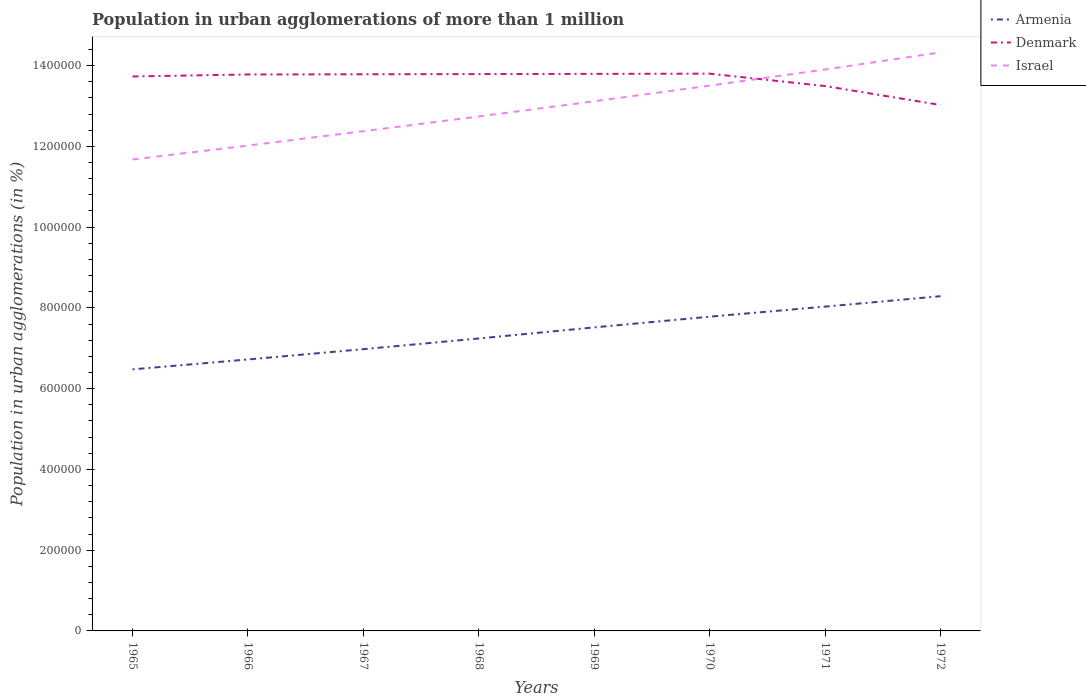Does the line corresponding to Armenia intersect with the line corresponding to Israel?
Your answer should be very brief. No. Across all years, what is the maximum population in urban agglomerations in Armenia?
Offer a very short reply. 6.48e+05. In which year was the population in urban agglomerations in Israel maximum?
Make the answer very short. 1965. What is the total population in urban agglomerations in Israel in the graph?
Offer a terse response. -2.65e+05. What is the difference between the highest and the second highest population in urban agglomerations in Armenia?
Your answer should be very brief. 1.81e+05. What is the difference between two consecutive major ticks on the Y-axis?
Your response must be concise. 2.00e+05. Does the graph contain any zero values?
Give a very brief answer. No. Does the graph contain grids?
Your answer should be compact. No. Where does the legend appear in the graph?
Give a very brief answer. Top right. How are the legend labels stacked?
Give a very brief answer. Vertical. What is the title of the graph?
Provide a short and direct response. Population in urban agglomerations of more than 1 million. What is the label or title of the X-axis?
Provide a succinct answer. Years. What is the label or title of the Y-axis?
Your answer should be very brief. Population in urban agglomerations (in %). What is the Population in urban agglomerations (in %) in Armenia in 1965?
Your answer should be compact. 6.48e+05. What is the Population in urban agglomerations (in %) in Denmark in 1965?
Provide a short and direct response. 1.37e+06. What is the Population in urban agglomerations (in %) of Israel in 1965?
Offer a very short reply. 1.17e+06. What is the Population in urban agglomerations (in %) of Armenia in 1966?
Your answer should be very brief. 6.72e+05. What is the Population in urban agglomerations (in %) of Denmark in 1966?
Make the answer very short. 1.38e+06. What is the Population in urban agglomerations (in %) in Israel in 1966?
Offer a terse response. 1.20e+06. What is the Population in urban agglomerations (in %) of Armenia in 1967?
Ensure brevity in your answer.  6.98e+05. What is the Population in urban agglomerations (in %) of Denmark in 1967?
Your answer should be very brief. 1.38e+06. What is the Population in urban agglomerations (in %) of Israel in 1967?
Provide a succinct answer. 1.24e+06. What is the Population in urban agglomerations (in %) of Armenia in 1968?
Keep it short and to the point. 7.24e+05. What is the Population in urban agglomerations (in %) in Denmark in 1968?
Offer a very short reply. 1.38e+06. What is the Population in urban agglomerations (in %) of Israel in 1968?
Your answer should be very brief. 1.27e+06. What is the Population in urban agglomerations (in %) of Armenia in 1969?
Give a very brief answer. 7.52e+05. What is the Population in urban agglomerations (in %) of Denmark in 1969?
Keep it short and to the point. 1.38e+06. What is the Population in urban agglomerations (in %) in Israel in 1969?
Offer a very short reply. 1.31e+06. What is the Population in urban agglomerations (in %) in Armenia in 1970?
Offer a very short reply. 7.78e+05. What is the Population in urban agglomerations (in %) in Denmark in 1970?
Ensure brevity in your answer.  1.38e+06. What is the Population in urban agglomerations (in %) in Israel in 1970?
Offer a terse response. 1.35e+06. What is the Population in urban agglomerations (in %) of Armenia in 1971?
Your answer should be very brief. 8.03e+05. What is the Population in urban agglomerations (in %) in Denmark in 1971?
Your answer should be compact. 1.35e+06. What is the Population in urban agglomerations (in %) of Israel in 1971?
Give a very brief answer. 1.39e+06. What is the Population in urban agglomerations (in %) of Armenia in 1972?
Your answer should be very brief. 8.29e+05. What is the Population in urban agglomerations (in %) in Denmark in 1972?
Offer a very short reply. 1.30e+06. What is the Population in urban agglomerations (in %) in Israel in 1972?
Give a very brief answer. 1.43e+06. Across all years, what is the maximum Population in urban agglomerations (in %) in Armenia?
Your answer should be very brief. 8.29e+05. Across all years, what is the maximum Population in urban agglomerations (in %) in Denmark?
Keep it short and to the point. 1.38e+06. Across all years, what is the maximum Population in urban agglomerations (in %) in Israel?
Ensure brevity in your answer.  1.43e+06. Across all years, what is the minimum Population in urban agglomerations (in %) in Armenia?
Ensure brevity in your answer.  6.48e+05. Across all years, what is the minimum Population in urban agglomerations (in %) in Denmark?
Offer a very short reply. 1.30e+06. Across all years, what is the minimum Population in urban agglomerations (in %) of Israel?
Ensure brevity in your answer.  1.17e+06. What is the total Population in urban agglomerations (in %) in Armenia in the graph?
Offer a terse response. 5.90e+06. What is the total Population in urban agglomerations (in %) in Denmark in the graph?
Your answer should be compact. 1.09e+07. What is the total Population in urban agglomerations (in %) in Israel in the graph?
Your answer should be very brief. 1.04e+07. What is the difference between the Population in urban agglomerations (in %) of Armenia in 1965 and that in 1966?
Make the answer very short. -2.46e+04. What is the difference between the Population in urban agglomerations (in %) in Denmark in 1965 and that in 1966?
Provide a short and direct response. -4922. What is the difference between the Population in urban agglomerations (in %) of Israel in 1965 and that in 1966?
Keep it short and to the point. -3.45e+04. What is the difference between the Population in urban agglomerations (in %) of Armenia in 1965 and that in 1967?
Ensure brevity in your answer.  -5.00e+04. What is the difference between the Population in urban agglomerations (in %) in Denmark in 1965 and that in 1967?
Make the answer very short. -5430. What is the difference between the Population in urban agglomerations (in %) of Israel in 1965 and that in 1967?
Your answer should be compact. -6.99e+04. What is the difference between the Population in urban agglomerations (in %) of Armenia in 1965 and that in 1968?
Provide a succinct answer. -7.65e+04. What is the difference between the Population in urban agglomerations (in %) of Denmark in 1965 and that in 1968?
Ensure brevity in your answer.  -5938. What is the difference between the Population in urban agglomerations (in %) in Israel in 1965 and that in 1968?
Give a very brief answer. -1.07e+05. What is the difference between the Population in urban agglomerations (in %) of Armenia in 1965 and that in 1969?
Your response must be concise. -1.04e+05. What is the difference between the Population in urban agglomerations (in %) in Denmark in 1965 and that in 1969?
Provide a succinct answer. -6445. What is the difference between the Population in urban agglomerations (in %) in Israel in 1965 and that in 1969?
Provide a succinct answer. -1.44e+05. What is the difference between the Population in urban agglomerations (in %) of Armenia in 1965 and that in 1970?
Your answer should be compact. -1.30e+05. What is the difference between the Population in urban agglomerations (in %) in Denmark in 1965 and that in 1970?
Your answer should be very brief. -6954. What is the difference between the Population in urban agglomerations (in %) in Israel in 1965 and that in 1970?
Give a very brief answer. -1.83e+05. What is the difference between the Population in urban agglomerations (in %) in Armenia in 1965 and that in 1971?
Provide a succinct answer. -1.55e+05. What is the difference between the Population in urban agglomerations (in %) of Denmark in 1965 and that in 1971?
Your answer should be compact. 2.37e+04. What is the difference between the Population in urban agglomerations (in %) of Israel in 1965 and that in 1971?
Ensure brevity in your answer.  -2.23e+05. What is the difference between the Population in urban agglomerations (in %) in Armenia in 1965 and that in 1972?
Your answer should be compact. -1.81e+05. What is the difference between the Population in urban agglomerations (in %) in Denmark in 1965 and that in 1972?
Give a very brief answer. 7.06e+04. What is the difference between the Population in urban agglomerations (in %) in Israel in 1965 and that in 1972?
Provide a succinct answer. -2.65e+05. What is the difference between the Population in urban agglomerations (in %) in Armenia in 1966 and that in 1967?
Offer a terse response. -2.55e+04. What is the difference between the Population in urban agglomerations (in %) in Denmark in 1966 and that in 1967?
Provide a succinct answer. -508. What is the difference between the Population in urban agglomerations (in %) of Israel in 1966 and that in 1967?
Make the answer very short. -3.55e+04. What is the difference between the Population in urban agglomerations (in %) of Armenia in 1966 and that in 1968?
Make the answer very short. -5.20e+04. What is the difference between the Population in urban agglomerations (in %) of Denmark in 1966 and that in 1968?
Ensure brevity in your answer.  -1016. What is the difference between the Population in urban agglomerations (in %) of Israel in 1966 and that in 1968?
Keep it short and to the point. -7.21e+04. What is the difference between the Population in urban agglomerations (in %) in Armenia in 1966 and that in 1969?
Offer a very short reply. -7.94e+04. What is the difference between the Population in urban agglomerations (in %) in Denmark in 1966 and that in 1969?
Your answer should be very brief. -1523. What is the difference between the Population in urban agglomerations (in %) in Israel in 1966 and that in 1969?
Your response must be concise. -1.10e+05. What is the difference between the Population in urban agglomerations (in %) of Armenia in 1966 and that in 1970?
Offer a terse response. -1.06e+05. What is the difference between the Population in urban agglomerations (in %) in Denmark in 1966 and that in 1970?
Make the answer very short. -2032. What is the difference between the Population in urban agglomerations (in %) of Israel in 1966 and that in 1970?
Give a very brief answer. -1.48e+05. What is the difference between the Population in urban agglomerations (in %) of Armenia in 1966 and that in 1971?
Your answer should be very brief. -1.31e+05. What is the difference between the Population in urban agglomerations (in %) of Denmark in 1966 and that in 1971?
Provide a succinct answer. 2.87e+04. What is the difference between the Population in urban agglomerations (in %) of Israel in 1966 and that in 1971?
Offer a terse response. -1.88e+05. What is the difference between the Population in urban agglomerations (in %) of Armenia in 1966 and that in 1972?
Offer a very short reply. -1.57e+05. What is the difference between the Population in urban agglomerations (in %) in Denmark in 1966 and that in 1972?
Keep it short and to the point. 7.55e+04. What is the difference between the Population in urban agglomerations (in %) in Israel in 1966 and that in 1972?
Provide a succinct answer. -2.31e+05. What is the difference between the Population in urban agglomerations (in %) of Armenia in 1967 and that in 1968?
Your answer should be compact. -2.65e+04. What is the difference between the Population in urban agglomerations (in %) of Denmark in 1967 and that in 1968?
Your response must be concise. -508. What is the difference between the Population in urban agglomerations (in %) of Israel in 1967 and that in 1968?
Make the answer very short. -3.66e+04. What is the difference between the Population in urban agglomerations (in %) in Armenia in 1967 and that in 1969?
Keep it short and to the point. -5.39e+04. What is the difference between the Population in urban agglomerations (in %) in Denmark in 1967 and that in 1969?
Your response must be concise. -1015. What is the difference between the Population in urban agglomerations (in %) of Israel in 1967 and that in 1969?
Make the answer very short. -7.42e+04. What is the difference between the Population in urban agglomerations (in %) of Armenia in 1967 and that in 1970?
Your answer should be compact. -8.04e+04. What is the difference between the Population in urban agglomerations (in %) of Denmark in 1967 and that in 1970?
Your response must be concise. -1524. What is the difference between the Population in urban agglomerations (in %) of Israel in 1967 and that in 1970?
Provide a succinct answer. -1.13e+05. What is the difference between the Population in urban agglomerations (in %) in Armenia in 1967 and that in 1971?
Provide a short and direct response. -1.05e+05. What is the difference between the Population in urban agglomerations (in %) in Denmark in 1967 and that in 1971?
Your answer should be very brief. 2.92e+04. What is the difference between the Population in urban agglomerations (in %) of Israel in 1967 and that in 1971?
Make the answer very short. -1.53e+05. What is the difference between the Population in urban agglomerations (in %) of Armenia in 1967 and that in 1972?
Your response must be concise. -1.31e+05. What is the difference between the Population in urban agglomerations (in %) of Denmark in 1967 and that in 1972?
Give a very brief answer. 7.60e+04. What is the difference between the Population in urban agglomerations (in %) in Israel in 1967 and that in 1972?
Keep it short and to the point. -1.95e+05. What is the difference between the Population in urban agglomerations (in %) in Armenia in 1968 and that in 1969?
Provide a short and direct response. -2.74e+04. What is the difference between the Population in urban agglomerations (in %) of Denmark in 1968 and that in 1969?
Give a very brief answer. -507. What is the difference between the Population in urban agglomerations (in %) in Israel in 1968 and that in 1969?
Provide a short and direct response. -3.76e+04. What is the difference between the Population in urban agglomerations (in %) of Armenia in 1968 and that in 1970?
Your answer should be compact. -5.39e+04. What is the difference between the Population in urban agglomerations (in %) in Denmark in 1968 and that in 1970?
Your answer should be very brief. -1016. What is the difference between the Population in urban agglomerations (in %) in Israel in 1968 and that in 1970?
Provide a succinct answer. -7.64e+04. What is the difference between the Population in urban agglomerations (in %) of Armenia in 1968 and that in 1971?
Make the answer very short. -7.89e+04. What is the difference between the Population in urban agglomerations (in %) in Denmark in 1968 and that in 1971?
Your response must be concise. 2.97e+04. What is the difference between the Population in urban agglomerations (in %) in Israel in 1968 and that in 1971?
Offer a very short reply. -1.16e+05. What is the difference between the Population in urban agglomerations (in %) in Armenia in 1968 and that in 1972?
Ensure brevity in your answer.  -1.05e+05. What is the difference between the Population in urban agglomerations (in %) of Denmark in 1968 and that in 1972?
Provide a succinct answer. 7.65e+04. What is the difference between the Population in urban agglomerations (in %) of Israel in 1968 and that in 1972?
Make the answer very short. -1.59e+05. What is the difference between the Population in urban agglomerations (in %) of Armenia in 1969 and that in 1970?
Offer a very short reply. -2.65e+04. What is the difference between the Population in urban agglomerations (in %) in Denmark in 1969 and that in 1970?
Ensure brevity in your answer.  -509. What is the difference between the Population in urban agglomerations (in %) of Israel in 1969 and that in 1970?
Provide a succinct answer. -3.88e+04. What is the difference between the Population in urban agglomerations (in %) in Armenia in 1969 and that in 1971?
Offer a terse response. -5.14e+04. What is the difference between the Population in urban agglomerations (in %) of Denmark in 1969 and that in 1971?
Make the answer very short. 3.02e+04. What is the difference between the Population in urban agglomerations (in %) of Israel in 1969 and that in 1971?
Provide a short and direct response. -7.87e+04. What is the difference between the Population in urban agglomerations (in %) in Armenia in 1969 and that in 1972?
Offer a terse response. -7.72e+04. What is the difference between the Population in urban agglomerations (in %) in Denmark in 1969 and that in 1972?
Your answer should be compact. 7.70e+04. What is the difference between the Population in urban agglomerations (in %) in Israel in 1969 and that in 1972?
Your response must be concise. -1.21e+05. What is the difference between the Population in urban agglomerations (in %) in Armenia in 1970 and that in 1971?
Give a very brief answer. -2.50e+04. What is the difference between the Population in urban agglomerations (in %) in Denmark in 1970 and that in 1971?
Offer a terse response. 3.07e+04. What is the difference between the Population in urban agglomerations (in %) in Israel in 1970 and that in 1971?
Your answer should be compact. -3.99e+04. What is the difference between the Population in urban agglomerations (in %) of Armenia in 1970 and that in 1972?
Offer a terse response. -5.07e+04. What is the difference between the Population in urban agglomerations (in %) of Denmark in 1970 and that in 1972?
Provide a short and direct response. 7.76e+04. What is the difference between the Population in urban agglomerations (in %) in Israel in 1970 and that in 1972?
Give a very brief answer. -8.22e+04. What is the difference between the Population in urban agglomerations (in %) in Armenia in 1971 and that in 1972?
Provide a short and direct response. -2.58e+04. What is the difference between the Population in urban agglomerations (in %) of Denmark in 1971 and that in 1972?
Your answer should be compact. 4.69e+04. What is the difference between the Population in urban agglomerations (in %) of Israel in 1971 and that in 1972?
Your answer should be very brief. -4.23e+04. What is the difference between the Population in urban agglomerations (in %) in Armenia in 1965 and the Population in urban agglomerations (in %) in Denmark in 1966?
Give a very brief answer. -7.30e+05. What is the difference between the Population in urban agglomerations (in %) of Armenia in 1965 and the Population in urban agglomerations (in %) of Israel in 1966?
Provide a short and direct response. -5.54e+05. What is the difference between the Population in urban agglomerations (in %) of Denmark in 1965 and the Population in urban agglomerations (in %) of Israel in 1966?
Offer a terse response. 1.71e+05. What is the difference between the Population in urban agglomerations (in %) in Armenia in 1965 and the Population in urban agglomerations (in %) in Denmark in 1967?
Keep it short and to the point. -7.31e+05. What is the difference between the Population in urban agglomerations (in %) of Armenia in 1965 and the Population in urban agglomerations (in %) of Israel in 1967?
Provide a short and direct response. -5.90e+05. What is the difference between the Population in urban agglomerations (in %) of Denmark in 1965 and the Population in urban agglomerations (in %) of Israel in 1967?
Your response must be concise. 1.36e+05. What is the difference between the Population in urban agglomerations (in %) in Armenia in 1965 and the Population in urban agglomerations (in %) in Denmark in 1968?
Your response must be concise. -7.31e+05. What is the difference between the Population in urban agglomerations (in %) in Armenia in 1965 and the Population in urban agglomerations (in %) in Israel in 1968?
Provide a short and direct response. -6.26e+05. What is the difference between the Population in urban agglomerations (in %) in Denmark in 1965 and the Population in urban agglomerations (in %) in Israel in 1968?
Provide a short and direct response. 9.90e+04. What is the difference between the Population in urban agglomerations (in %) in Armenia in 1965 and the Population in urban agglomerations (in %) in Denmark in 1969?
Your answer should be very brief. -7.32e+05. What is the difference between the Population in urban agglomerations (in %) in Armenia in 1965 and the Population in urban agglomerations (in %) in Israel in 1969?
Make the answer very short. -6.64e+05. What is the difference between the Population in urban agglomerations (in %) in Denmark in 1965 and the Population in urban agglomerations (in %) in Israel in 1969?
Your answer should be compact. 6.14e+04. What is the difference between the Population in urban agglomerations (in %) of Armenia in 1965 and the Population in urban agglomerations (in %) of Denmark in 1970?
Provide a short and direct response. -7.32e+05. What is the difference between the Population in urban agglomerations (in %) of Armenia in 1965 and the Population in urban agglomerations (in %) of Israel in 1970?
Offer a very short reply. -7.03e+05. What is the difference between the Population in urban agglomerations (in %) in Denmark in 1965 and the Population in urban agglomerations (in %) in Israel in 1970?
Offer a very short reply. 2.27e+04. What is the difference between the Population in urban agglomerations (in %) in Armenia in 1965 and the Population in urban agglomerations (in %) in Denmark in 1971?
Provide a short and direct response. -7.02e+05. What is the difference between the Population in urban agglomerations (in %) in Armenia in 1965 and the Population in urban agglomerations (in %) in Israel in 1971?
Offer a terse response. -7.43e+05. What is the difference between the Population in urban agglomerations (in %) of Denmark in 1965 and the Population in urban agglomerations (in %) of Israel in 1971?
Provide a succinct answer. -1.73e+04. What is the difference between the Population in urban agglomerations (in %) of Armenia in 1965 and the Population in urban agglomerations (in %) of Denmark in 1972?
Offer a very short reply. -6.55e+05. What is the difference between the Population in urban agglomerations (in %) of Armenia in 1965 and the Population in urban agglomerations (in %) of Israel in 1972?
Provide a succinct answer. -7.85e+05. What is the difference between the Population in urban agglomerations (in %) of Denmark in 1965 and the Population in urban agglomerations (in %) of Israel in 1972?
Offer a very short reply. -5.95e+04. What is the difference between the Population in urban agglomerations (in %) of Armenia in 1966 and the Population in urban agglomerations (in %) of Denmark in 1967?
Your answer should be very brief. -7.06e+05. What is the difference between the Population in urban agglomerations (in %) in Armenia in 1966 and the Population in urban agglomerations (in %) in Israel in 1967?
Give a very brief answer. -5.65e+05. What is the difference between the Population in urban agglomerations (in %) in Denmark in 1966 and the Population in urban agglomerations (in %) in Israel in 1967?
Your answer should be compact. 1.41e+05. What is the difference between the Population in urban agglomerations (in %) of Armenia in 1966 and the Population in urban agglomerations (in %) of Denmark in 1968?
Offer a terse response. -7.07e+05. What is the difference between the Population in urban agglomerations (in %) of Armenia in 1966 and the Population in urban agglomerations (in %) of Israel in 1968?
Provide a succinct answer. -6.02e+05. What is the difference between the Population in urban agglomerations (in %) in Denmark in 1966 and the Population in urban agglomerations (in %) in Israel in 1968?
Make the answer very short. 1.04e+05. What is the difference between the Population in urban agglomerations (in %) in Armenia in 1966 and the Population in urban agglomerations (in %) in Denmark in 1969?
Provide a succinct answer. -7.07e+05. What is the difference between the Population in urban agglomerations (in %) of Armenia in 1966 and the Population in urban agglomerations (in %) of Israel in 1969?
Provide a short and direct response. -6.39e+05. What is the difference between the Population in urban agglomerations (in %) in Denmark in 1966 and the Population in urban agglomerations (in %) in Israel in 1969?
Keep it short and to the point. 6.64e+04. What is the difference between the Population in urban agglomerations (in %) in Armenia in 1966 and the Population in urban agglomerations (in %) in Denmark in 1970?
Offer a very short reply. -7.08e+05. What is the difference between the Population in urban agglomerations (in %) in Armenia in 1966 and the Population in urban agglomerations (in %) in Israel in 1970?
Offer a terse response. -6.78e+05. What is the difference between the Population in urban agglomerations (in %) in Denmark in 1966 and the Population in urban agglomerations (in %) in Israel in 1970?
Your response must be concise. 2.76e+04. What is the difference between the Population in urban agglomerations (in %) in Armenia in 1966 and the Population in urban agglomerations (in %) in Denmark in 1971?
Keep it short and to the point. -6.77e+05. What is the difference between the Population in urban agglomerations (in %) in Armenia in 1966 and the Population in urban agglomerations (in %) in Israel in 1971?
Your answer should be compact. -7.18e+05. What is the difference between the Population in urban agglomerations (in %) of Denmark in 1966 and the Population in urban agglomerations (in %) of Israel in 1971?
Provide a short and direct response. -1.23e+04. What is the difference between the Population in urban agglomerations (in %) of Armenia in 1966 and the Population in urban agglomerations (in %) of Denmark in 1972?
Your answer should be very brief. -6.30e+05. What is the difference between the Population in urban agglomerations (in %) in Armenia in 1966 and the Population in urban agglomerations (in %) in Israel in 1972?
Keep it short and to the point. -7.60e+05. What is the difference between the Population in urban agglomerations (in %) in Denmark in 1966 and the Population in urban agglomerations (in %) in Israel in 1972?
Provide a short and direct response. -5.46e+04. What is the difference between the Population in urban agglomerations (in %) of Armenia in 1967 and the Population in urban agglomerations (in %) of Denmark in 1968?
Your response must be concise. -6.81e+05. What is the difference between the Population in urban agglomerations (in %) in Armenia in 1967 and the Population in urban agglomerations (in %) in Israel in 1968?
Ensure brevity in your answer.  -5.76e+05. What is the difference between the Population in urban agglomerations (in %) of Denmark in 1967 and the Population in urban agglomerations (in %) of Israel in 1968?
Your answer should be compact. 1.04e+05. What is the difference between the Population in urban agglomerations (in %) of Armenia in 1967 and the Population in urban agglomerations (in %) of Denmark in 1969?
Ensure brevity in your answer.  -6.82e+05. What is the difference between the Population in urban agglomerations (in %) in Armenia in 1967 and the Population in urban agglomerations (in %) in Israel in 1969?
Your answer should be compact. -6.14e+05. What is the difference between the Population in urban agglomerations (in %) of Denmark in 1967 and the Population in urban agglomerations (in %) of Israel in 1969?
Provide a short and direct response. 6.69e+04. What is the difference between the Population in urban agglomerations (in %) in Armenia in 1967 and the Population in urban agglomerations (in %) in Denmark in 1970?
Your answer should be very brief. -6.82e+05. What is the difference between the Population in urban agglomerations (in %) in Armenia in 1967 and the Population in urban agglomerations (in %) in Israel in 1970?
Give a very brief answer. -6.53e+05. What is the difference between the Population in urban agglomerations (in %) in Denmark in 1967 and the Population in urban agglomerations (in %) in Israel in 1970?
Keep it short and to the point. 2.81e+04. What is the difference between the Population in urban agglomerations (in %) in Armenia in 1967 and the Population in urban agglomerations (in %) in Denmark in 1971?
Your response must be concise. -6.52e+05. What is the difference between the Population in urban agglomerations (in %) of Armenia in 1967 and the Population in urban agglomerations (in %) of Israel in 1971?
Keep it short and to the point. -6.93e+05. What is the difference between the Population in urban agglomerations (in %) in Denmark in 1967 and the Population in urban agglomerations (in %) in Israel in 1971?
Provide a succinct answer. -1.18e+04. What is the difference between the Population in urban agglomerations (in %) of Armenia in 1967 and the Population in urban agglomerations (in %) of Denmark in 1972?
Your answer should be very brief. -6.05e+05. What is the difference between the Population in urban agglomerations (in %) in Armenia in 1967 and the Population in urban agglomerations (in %) in Israel in 1972?
Offer a terse response. -7.35e+05. What is the difference between the Population in urban agglomerations (in %) of Denmark in 1967 and the Population in urban agglomerations (in %) of Israel in 1972?
Give a very brief answer. -5.41e+04. What is the difference between the Population in urban agglomerations (in %) of Armenia in 1968 and the Population in urban agglomerations (in %) of Denmark in 1969?
Keep it short and to the point. -6.55e+05. What is the difference between the Population in urban agglomerations (in %) in Armenia in 1968 and the Population in urban agglomerations (in %) in Israel in 1969?
Your response must be concise. -5.87e+05. What is the difference between the Population in urban agglomerations (in %) in Denmark in 1968 and the Population in urban agglomerations (in %) in Israel in 1969?
Provide a succinct answer. 6.74e+04. What is the difference between the Population in urban agglomerations (in %) of Armenia in 1968 and the Population in urban agglomerations (in %) of Denmark in 1970?
Give a very brief answer. -6.56e+05. What is the difference between the Population in urban agglomerations (in %) in Armenia in 1968 and the Population in urban agglomerations (in %) in Israel in 1970?
Keep it short and to the point. -6.26e+05. What is the difference between the Population in urban agglomerations (in %) in Denmark in 1968 and the Population in urban agglomerations (in %) in Israel in 1970?
Offer a very short reply. 2.86e+04. What is the difference between the Population in urban agglomerations (in %) in Armenia in 1968 and the Population in urban agglomerations (in %) in Denmark in 1971?
Ensure brevity in your answer.  -6.25e+05. What is the difference between the Population in urban agglomerations (in %) of Armenia in 1968 and the Population in urban agglomerations (in %) of Israel in 1971?
Give a very brief answer. -6.66e+05. What is the difference between the Population in urban agglomerations (in %) of Denmark in 1968 and the Population in urban agglomerations (in %) of Israel in 1971?
Your response must be concise. -1.13e+04. What is the difference between the Population in urban agglomerations (in %) of Armenia in 1968 and the Population in urban agglomerations (in %) of Denmark in 1972?
Provide a short and direct response. -5.78e+05. What is the difference between the Population in urban agglomerations (in %) of Armenia in 1968 and the Population in urban agglomerations (in %) of Israel in 1972?
Provide a succinct answer. -7.08e+05. What is the difference between the Population in urban agglomerations (in %) in Denmark in 1968 and the Population in urban agglomerations (in %) in Israel in 1972?
Your response must be concise. -5.36e+04. What is the difference between the Population in urban agglomerations (in %) in Armenia in 1969 and the Population in urban agglomerations (in %) in Denmark in 1970?
Offer a terse response. -6.28e+05. What is the difference between the Population in urban agglomerations (in %) in Armenia in 1969 and the Population in urban agglomerations (in %) in Israel in 1970?
Keep it short and to the point. -5.99e+05. What is the difference between the Population in urban agglomerations (in %) of Denmark in 1969 and the Population in urban agglomerations (in %) of Israel in 1970?
Offer a terse response. 2.91e+04. What is the difference between the Population in urban agglomerations (in %) of Armenia in 1969 and the Population in urban agglomerations (in %) of Denmark in 1971?
Your answer should be very brief. -5.98e+05. What is the difference between the Population in urban agglomerations (in %) of Armenia in 1969 and the Population in urban agglomerations (in %) of Israel in 1971?
Your answer should be very brief. -6.39e+05. What is the difference between the Population in urban agglomerations (in %) in Denmark in 1969 and the Population in urban agglomerations (in %) in Israel in 1971?
Make the answer very short. -1.08e+04. What is the difference between the Population in urban agglomerations (in %) in Armenia in 1969 and the Population in urban agglomerations (in %) in Denmark in 1972?
Your response must be concise. -5.51e+05. What is the difference between the Population in urban agglomerations (in %) in Armenia in 1969 and the Population in urban agglomerations (in %) in Israel in 1972?
Offer a terse response. -6.81e+05. What is the difference between the Population in urban agglomerations (in %) in Denmark in 1969 and the Population in urban agglomerations (in %) in Israel in 1972?
Your answer should be compact. -5.31e+04. What is the difference between the Population in urban agglomerations (in %) in Armenia in 1970 and the Population in urban agglomerations (in %) in Denmark in 1971?
Provide a succinct answer. -5.71e+05. What is the difference between the Population in urban agglomerations (in %) of Armenia in 1970 and the Population in urban agglomerations (in %) of Israel in 1971?
Your response must be concise. -6.12e+05. What is the difference between the Population in urban agglomerations (in %) of Denmark in 1970 and the Population in urban agglomerations (in %) of Israel in 1971?
Provide a succinct answer. -1.03e+04. What is the difference between the Population in urban agglomerations (in %) in Armenia in 1970 and the Population in urban agglomerations (in %) in Denmark in 1972?
Your answer should be very brief. -5.24e+05. What is the difference between the Population in urban agglomerations (in %) of Armenia in 1970 and the Population in urban agglomerations (in %) of Israel in 1972?
Keep it short and to the point. -6.54e+05. What is the difference between the Population in urban agglomerations (in %) of Denmark in 1970 and the Population in urban agglomerations (in %) of Israel in 1972?
Your answer should be very brief. -5.26e+04. What is the difference between the Population in urban agglomerations (in %) of Armenia in 1971 and the Population in urban agglomerations (in %) of Denmark in 1972?
Give a very brief answer. -4.99e+05. What is the difference between the Population in urban agglomerations (in %) in Armenia in 1971 and the Population in urban agglomerations (in %) in Israel in 1972?
Your response must be concise. -6.29e+05. What is the difference between the Population in urban agglomerations (in %) in Denmark in 1971 and the Population in urban agglomerations (in %) in Israel in 1972?
Offer a terse response. -8.33e+04. What is the average Population in urban agglomerations (in %) of Armenia per year?
Your response must be concise. 7.38e+05. What is the average Population in urban agglomerations (in %) in Denmark per year?
Make the answer very short. 1.36e+06. What is the average Population in urban agglomerations (in %) of Israel per year?
Make the answer very short. 1.30e+06. In the year 1965, what is the difference between the Population in urban agglomerations (in %) of Armenia and Population in urban agglomerations (in %) of Denmark?
Offer a terse response. -7.25e+05. In the year 1965, what is the difference between the Population in urban agglomerations (in %) of Armenia and Population in urban agglomerations (in %) of Israel?
Your answer should be very brief. -5.20e+05. In the year 1965, what is the difference between the Population in urban agglomerations (in %) in Denmark and Population in urban agglomerations (in %) in Israel?
Offer a terse response. 2.06e+05. In the year 1966, what is the difference between the Population in urban agglomerations (in %) of Armenia and Population in urban agglomerations (in %) of Denmark?
Make the answer very short. -7.06e+05. In the year 1966, what is the difference between the Population in urban agglomerations (in %) in Armenia and Population in urban agglomerations (in %) in Israel?
Offer a very short reply. -5.30e+05. In the year 1966, what is the difference between the Population in urban agglomerations (in %) in Denmark and Population in urban agglomerations (in %) in Israel?
Provide a short and direct response. 1.76e+05. In the year 1967, what is the difference between the Population in urban agglomerations (in %) of Armenia and Population in urban agglomerations (in %) of Denmark?
Give a very brief answer. -6.81e+05. In the year 1967, what is the difference between the Population in urban agglomerations (in %) of Armenia and Population in urban agglomerations (in %) of Israel?
Keep it short and to the point. -5.40e+05. In the year 1967, what is the difference between the Population in urban agglomerations (in %) in Denmark and Population in urban agglomerations (in %) in Israel?
Offer a very short reply. 1.41e+05. In the year 1968, what is the difference between the Population in urban agglomerations (in %) of Armenia and Population in urban agglomerations (in %) of Denmark?
Provide a succinct answer. -6.55e+05. In the year 1968, what is the difference between the Population in urban agglomerations (in %) in Armenia and Population in urban agglomerations (in %) in Israel?
Offer a terse response. -5.50e+05. In the year 1968, what is the difference between the Population in urban agglomerations (in %) in Denmark and Population in urban agglomerations (in %) in Israel?
Provide a short and direct response. 1.05e+05. In the year 1969, what is the difference between the Population in urban agglomerations (in %) in Armenia and Population in urban agglomerations (in %) in Denmark?
Your answer should be compact. -6.28e+05. In the year 1969, what is the difference between the Population in urban agglomerations (in %) in Armenia and Population in urban agglomerations (in %) in Israel?
Keep it short and to the point. -5.60e+05. In the year 1969, what is the difference between the Population in urban agglomerations (in %) in Denmark and Population in urban agglomerations (in %) in Israel?
Your answer should be compact. 6.79e+04. In the year 1970, what is the difference between the Population in urban agglomerations (in %) in Armenia and Population in urban agglomerations (in %) in Denmark?
Offer a very short reply. -6.02e+05. In the year 1970, what is the difference between the Population in urban agglomerations (in %) in Armenia and Population in urban agglomerations (in %) in Israel?
Provide a succinct answer. -5.72e+05. In the year 1970, what is the difference between the Population in urban agglomerations (in %) of Denmark and Population in urban agglomerations (in %) of Israel?
Provide a succinct answer. 2.96e+04. In the year 1971, what is the difference between the Population in urban agglomerations (in %) in Armenia and Population in urban agglomerations (in %) in Denmark?
Offer a very short reply. -5.46e+05. In the year 1971, what is the difference between the Population in urban agglomerations (in %) in Armenia and Population in urban agglomerations (in %) in Israel?
Offer a very short reply. -5.87e+05. In the year 1971, what is the difference between the Population in urban agglomerations (in %) in Denmark and Population in urban agglomerations (in %) in Israel?
Your answer should be compact. -4.10e+04. In the year 1972, what is the difference between the Population in urban agglomerations (in %) in Armenia and Population in urban agglomerations (in %) in Denmark?
Offer a very short reply. -4.74e+05. In the year 1972, what is the difference between the Population in urban agglomerations (in %) of Armenia and Population in urban agglomerations (in %) of Israel?
Your answer should be compact. -6.04e+05. In the year 1972, what is the difference between the Population in urban agglomerations (in %) of Denmark and Population in urban agglomerations (in %) of Israel?
Give a very brief answer. -1.30e+05. What is the ratio of the Population in urban agglomerations (in %) in Armenia in 1965 to that in 1966?
Your answer should be very brief. 0.96. What is the ratio of the Population in urban agglomerations (in %) of Denmark in 1965 to that in 1966?
Provide a short and direct response. 1. What is the ratio of the Population in urban agglomerations (in %) of Israel in 1965 to that in 1966?
Provide a short and direct response. 0.97. What is the ratio of the Population in urban agglomerations (in %) in Armenia in 1965 to that in 1967?
Offer a very short reply. 0.93. What is the ratio of the Population in urban agglomerations (in %) of Denmark in 1965 to that in 1967?
Provide a succinct answer. 1. What is the ratio of the Population in urban agglomerations (in %) in Israel in 1965 to that in 1967?
Offer a terse response. 0.94. What is the ratio of the Population in urban agglomerations (in %) of Armenia in 1965 to that in 1968?
Your response must be concise. 0.89. What is the ratio of the Population in urban agglomerations (in %) in Denmark in 1965 to that in 1968?
Offer a terse response. 1. What is the ratio of the Population in urban agglomerations (in %) of Israel in 1965 to that in 1968?
Make the answer very short. 0.92. What is the ratio of the Population in urban agglomerations (in %) in Armenia in 1965 to that in 1969?
Provide a short and direct response. 0.86. What is the ratio of the Population in urban agglomerations (in %) of Israel in 1965 to that in 1969?
Provide a succinct answer. 0.89. What is the ratio of the Population in urban agglomerations (in %) in Armenia in 1965 to that in 1970?
Give a very brief answer. 0.83. What is the ratio of the Population in urban agglomerations (in %) of Denmark in 1965 to that in 1970?
Provide a short and direct response. 0.99. What is the ratio of the Population in urban agglomerations (in %) of Israel in 1965 to that in 1970?
Offer a terse response. 0.86. What is the ratio of the Population in urban agglomerations (in %) of Armenia in 1965 to that in 1971?
Make the answer very short. 0.81. What is the ratio of the Population in urban agglomerations (in %) of Denmark in 1965 to that in 1971?
Provide a short and direct response. 1.02. What is the ratio of the Population in urban agglomerations (in %) in Israel in 1965 to that in 1971?
Give a very brief answer. 0.84. What is the ratio of the Population in urban agglomerations (in %) of Armenia in 1965 to that in 1972?
Your answer should be very brief. 0.78. What is the ratio of the Population in urban agglomerations (in %) of Denmark in 1965 to that in 1972?
Offer a terse response. 1.05. What is the ratio of the Population in urban agglomerations (in %) in Israel in 1965 to that in 1972?
Your answer should be very brief. 0.81. What is the ratio of the Population in urban agglomerations (in %) in Armenia in 1966 to that in 1967?
Your answer should be compact. 0.96. What is the ratio of the Population in urban agglomerations (in %) in Israel in 1966 to that in 1967?
Give a very brief answer. 0.97. What is the ratio of the Population in urban agglomerations (in %) in Armenia in 1966 to that in 1968?
Give a very brief answer. 0.93. What is the ratio of the Population in urban agglomerations (in %) of Israel in 1966 to that in 1968?
Ensure brevity in your answer.  0.94. What is the ratio of the Population in urban agglomerations (in %) of Armenia in 1966 to that in 1969?
Your answer should be compact. 0.89. What is the ratio of the Population in urban agglomerations (in %) in Israel in 1966 to that in 1969?
Ensure brevity in your answer.  0.92. What is the ratio of the Population in urban agglomerations (in %) in Armenia in 1966 to that in 1970?
Keep it short and to the point. 0.86. What is the ratio of the Population in urban agglomerations (in %) in Denmark in 1966 to that in 1970?
Keep it short and to the point. 1. What is the ratio of the Population in urban agglomerations (in %) in Israel in 1966 to that in 1970?
Give a very brief answer. 0.89. What is the ratio of the Population in urban agglomerations (in %) in Armenia in 1966 to that in 1971?
Provide a succinct answer. 0.84. What is the ratio of the Population in urban agglomerations (in %) in Denmark in 1966 to that in 1971?
Offer a very short reply. 1.02. What is the ratio of the Population in urban agglomerations (in %) in Israel in 1966 to that in 1971?
Keep it short and to the point. 0.86. What is the ratio of the Population in urban agglomerations (in %) in Armenia in 1966 to that in 1972?
Make the answer very short. 0.81. What is the ratio of the Population in urban agglomerations (in %) in Denmark in 1966 to that in 1972?
Keep it short and to the point. 1.06. What is the ratio of the Population in urban agglomerations (in %) in Israel in 1966 to that in 1972?
Keep it short and to the point. 0.84. What is the ratio of the Population in urban agglomerations (in %) in Armenia in 1967 to that in 1968?
Give a very brief answer. 0.96. What is the ratio of the Population in urban agglomerations (in %) of Israel in 1967 to that in 1968?
Offer a very short reply. 0.97. What is the ratio of the Population in urban agglomerations (in %) in Armenia in 1967 to that in 1969?
Provide a succinct answer. 0.93. What is the ratio of the Population in urban agglomerations (in %) of Denmark in 1967 to that in 1969?
Keep it short and to the point. 1. What is the ratio of the Population in urban agglomerations (in %) in Israel in 1967 to that in 1969?
Your answer should be very brief. 0.94. What is the ratio of the Population in urban agglomerations (in %) in Armenia in 1967 to that in 1970?
Ensure brevity in your answer.  0.9. What is the ratio of the Population in urban agglomerations (in %) in Denmark in 1967 to that in 1970?
Give a very brief answer. 1. What is the ratio of the Population in urban agglomerations (in %) in Israel in 1967 to that in 1970?
Keep it short and to the point. 0.92. What is the ratio of the Population in urban agglomerations (in %) in Armenia in 1967 to that in 1971?
Provide a succinct answer. 0.87. What is the ratio of the Population in urban agglomerations (in %) in Denmark in 1967 to that in 1971?
Give a very brief answer. 1.02. What is the ratio of the Population in urban agglomerations (in %) in Israel in 1967 to that in 1971?
Offer a very short reply. 0.89. What is the ratio of the Population in urban agglomerations (in %) in Armenia in 1967 to that in 1972?
Your response must be concise. 0.84. What is the ratio of the Population in urban agglomerations (in %) in Denmark in 1967 to that in 1972?
Ensure brevity in your answer.  1.06. What is the ratio of the Population in urban agglomerations (in %) of Israel in 1967 to that in 1972?
Ensure brevity in your answer.  0.86. What is the ratio of the Population in urban agglomerations (in %) in Armenia in 1968 to that in 1969?
Keep it short and to the point. 0.96. What is the ratio of the Population in urban agglomerations (in %) in Israel in 1968 to that in 1969?
Your response must be concise. 0.97. What is the ratio of the Population in urban agglomerations (in %) in Armenia in 1968 to that in 1970?
Offer a very short reply. 0.93. What is the ratio of the Population in urban agglomerations (in %) of Denmark in 1968 to that in 1970?
Provide a short and direct response. 1. What is the ratio of the Population in urban agglomerations (in %) of Israel in 1968 to that in 1970?
Offer a very short reply. 0.94. What is the ratio of the Population in urban agglomerations (in %) in Armenia in 1968 to that in 1971?
Give a very brief answer. 0.9. What is the ratio of the Population in urban agglomerations (in %) in Israel in 1968 to that in 1971?
Keep it short and to the point. 0.92. What is the ratio of the Population in urban agglomerations (in %) of Armenia in 1968 to that in 1972?
Keep it short and to the point. 0.87. What is the ratio of the Population in urban agglomerations (in %) of Denmark in 1968 to that in 1972?
Make the answer very short. 1.06. What is the ratio of the Population in urban agglomerations (in %) of Israel in 1968 to that in 1972?
Offer a terse response. 0.89. What is the ratio of the Population in urban agglomerations (in %) in Armenia in 1969 to that in 1970?
Offer a terse response. 0.97. What is the ratio of the Population in urban agglomerations (in %) of Israel in 1969 to that in 1970?
Offer a terse response. 0.97. What is the ratio of the Population in urban agglomerations (in %) in Armenia in 1969 to that in 1971?
Make the answer very short. 0.94. What is the ratio of the Population in urban agglomerations (in %) of Denmark in 1969 to that in 1971?
Your answer should be compact. 1.02. What is the ratio of the Population in urban agglomerations (in %) of Israel in 1969 to that in 1971?
Make the answer very short. 0.94. What is the ratio of the Population in urban agglomerations (in %) in Armenia in 1969 to that in 1972?
Make the answer very short. 0.91. What is the ratio of the Population in urban agglomerations (in %) in Denmark in 1969 to that in 1972?
Make the answer very short. 1.06. What is the ratio of the Population in urban agglomerations (in %) in Israel in 1969 to that in 1972?
Make the answer very short. 0.92. What is the ratio of the Population in urban agglomerations (in %) in Armenia in 1970 to that in 1971?
Keep it short and to the point. 0.97. What is the ratio of the Population in urban agglomerations (in %) in Denmark in 1970 to that in 1971?
Your answer should be compact. 1.02. What is the ratio of the Population in urban agglomerations (in %) of Israel in 1970 to that in 1971?
Ensure brevity in your answer.  0.97. What is the ratio of the Population in urban agglomerations (in %) in Armenia in 1970 to that in 1972?
Make the answer very short. 0.94. What is the ratio of the Population in urban agglomerations (in %) in Denmark in 1970 to that in 1972?
Your answer should be compact. 1.06. What is the ratio of the Population in urban agglomerations (in %) of Israel in 1970 to that in 1972?
Offer a terse response. 0.94. What is the ratio of the Population in urban agglomerations (in %) of Armenia in 1971 to that in 1972?
Your answer should be very brief. 0.97. What is the ratio of the Population in urban agglomerations (in %) in Denmark in 1971 to that in 1972?
Make the answer very short. 1.04. What is the ratio of the Population in urban agglomerations (in %) in Israel in 1971 to that in 1972?
Make the answer very short. 0.97. What is the difference between the highest and the second highest Population in urban agglomerations (in %) in Armenia?
Make the answer very short. 2.58e+04. What is the difference between the highest and the second highest Population in urban agglomerations (in %) in Denmark?
Offer a terse response. 509. What is the difference between the highest and the second highest Population in urban agglomerations (in %) of Israel?
Your answer should be compact. 4.23e+04. What is the difference between the highest and the lowest Population in urban agglomerations (in %) in Armenia?
Your response must be concise. 1.81e+05. What is the difference between the highest and the lowest Population in urban agglomerations (in %) in Denmark?
Ensure brevity in your answer.  7.76e+04. What is the difference between the highest and the lowest Population in urban agglomerations (in %) of Israel?
Your answer should be compact. 2.65e+05. 